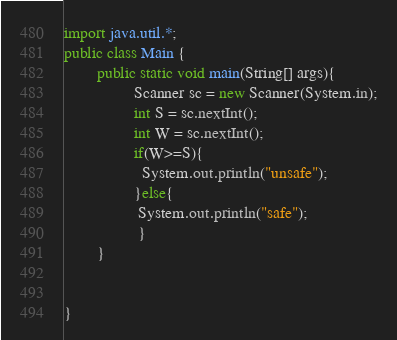Convert code to text. <code><loc_0><loc_0><loc_500><loc_500><_Java_>import java.util.*;
public class Main {
        public static void main(String[] args){
                 Scanner sc = new Scanner(System.in);
                 int S = sc.nextInt();
                 int W = sc.nextInt();
                 if(W>=S){
                   System.out.println("unsafe");
                 }else{
                  System.out.println("safe");
                  } 
        }
  
  
}</code> 